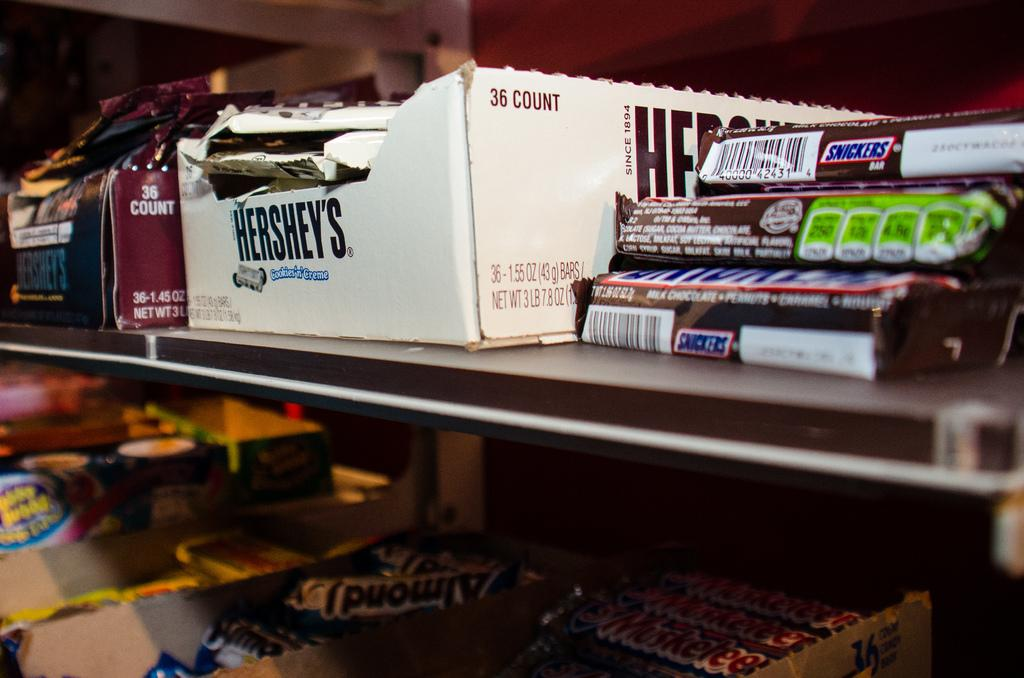<image>
Give a short and clear explanation of the subsequent image. Snickers candy bars on a shelf and 3 Muskateers candy bars on another shelf.. 